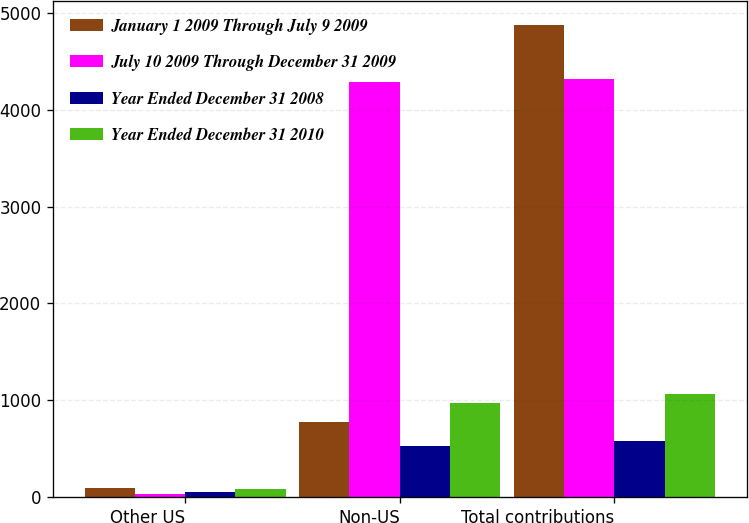<chart> <loc_0><loc_0><loc_500><loc_500><stacked_bar_chart><ecel><fcel>Other US<fcel>Non-US<fcel>Total contributions<nl><fcel>January 1 2009 Through July 9 2009<fcel>95<fcel>777<fcel>4872<nl><fcel>July 10 2009 Through December 31 2009<fcel>31<fcel>4287<fcel>4318<nl><fcel>Year Ended December 31 2008<fcel>57<fcel>529<fcel>586<nl><fcel>Year Ended December 31 2010<fcel>90<fcel>977<fcel>1067<nl></chart> 